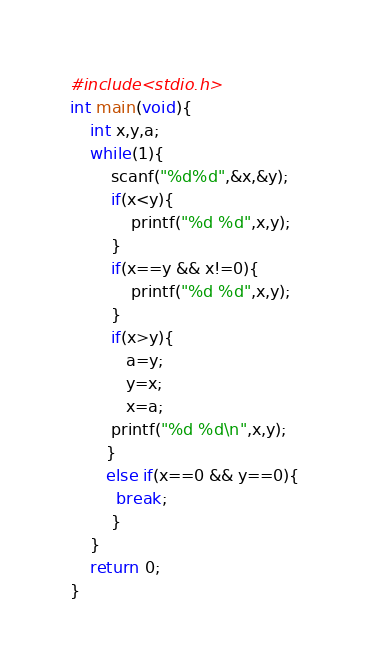Convert code to text. <code><loc_0><loc_0><loc_500><loc_500><_C++_>#include<stdio.h>
int main(void){
    int x,y,a;
    while(1){
        scanf("%d%d",&x,&y);
        if(x<y){
            printf("%d %d",x,y);
        }
        if(x==y && x!=0){
            printf("%d %d",x,y);
        }
        if(x>y){
           a=y;
           y=x;
           x=a;
        printf("%d %d\n",x,y);
       }
       else if(x==0 && y==0){
         break;
        }
    }
    return 0;
}</code> 